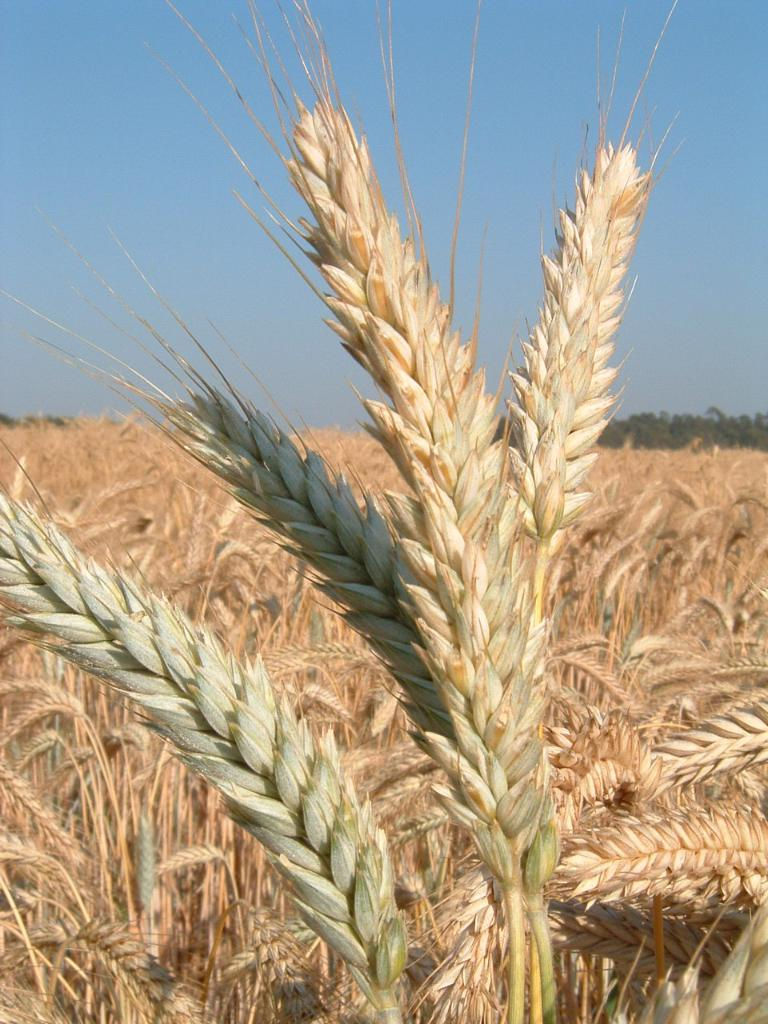What type of plants are in the front of the image? There are grains plants in the front of the image. What can be seen in the background of the image? There are trees and the sky visible in the background of the image. What type of wax can be seen dripping from the trees in the image? There is no wax present in the image; the trees are not depicted as having any wax dripping from them. 